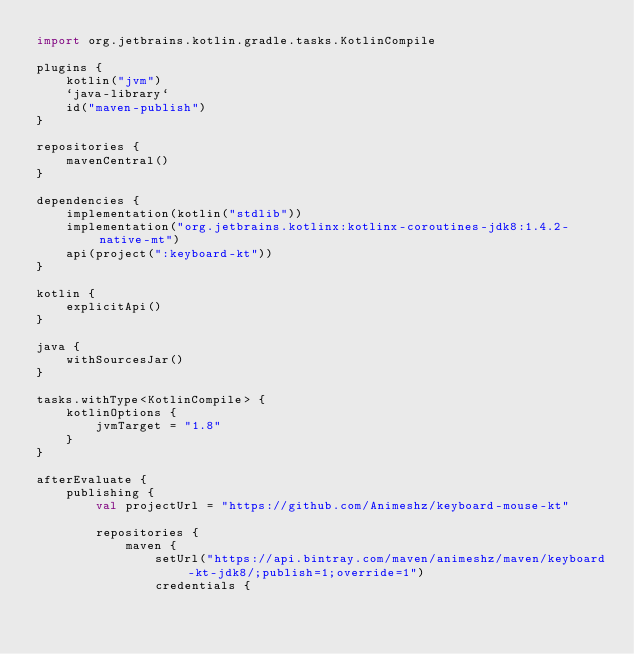Convert code to text. <code><loc_0><loc_0><loc_500><loc_500><_Kotlin_>import org.jetbrains.kotlin.gradle.tasks.KotlinCompile

plugins {
    kotlin("jvm")
    `java-library`
    id("maven-publish")
}

repositories {
    mavenCentral()
}

dependencies {
    implementation(kotlin("stdlib"))
    implementation("org.jetbrains.kotlinx:kotlinx-coroutines-jdk8:1.4.2-native-mt")
    api(project(":keyboard-kt"))
}

kotlin {
    explicitApi()
}

java {
    withSourcesJar()
}

tasks.withType<KotlinCompile> {
    kotlinOptions {
        jvmTarget = "1.8"
    }
}

afterEvaluate {
    publishing {
        val projectUrl = "https://github.com/Animeshz/keyboard-mouse-kt"

        repositories {
            maven {
                setUrl("https://api.bintray.com/maven/animeshz/maven/keyboard-kt-jdk8/;publish=1;override=1")
                credentials {</code> 